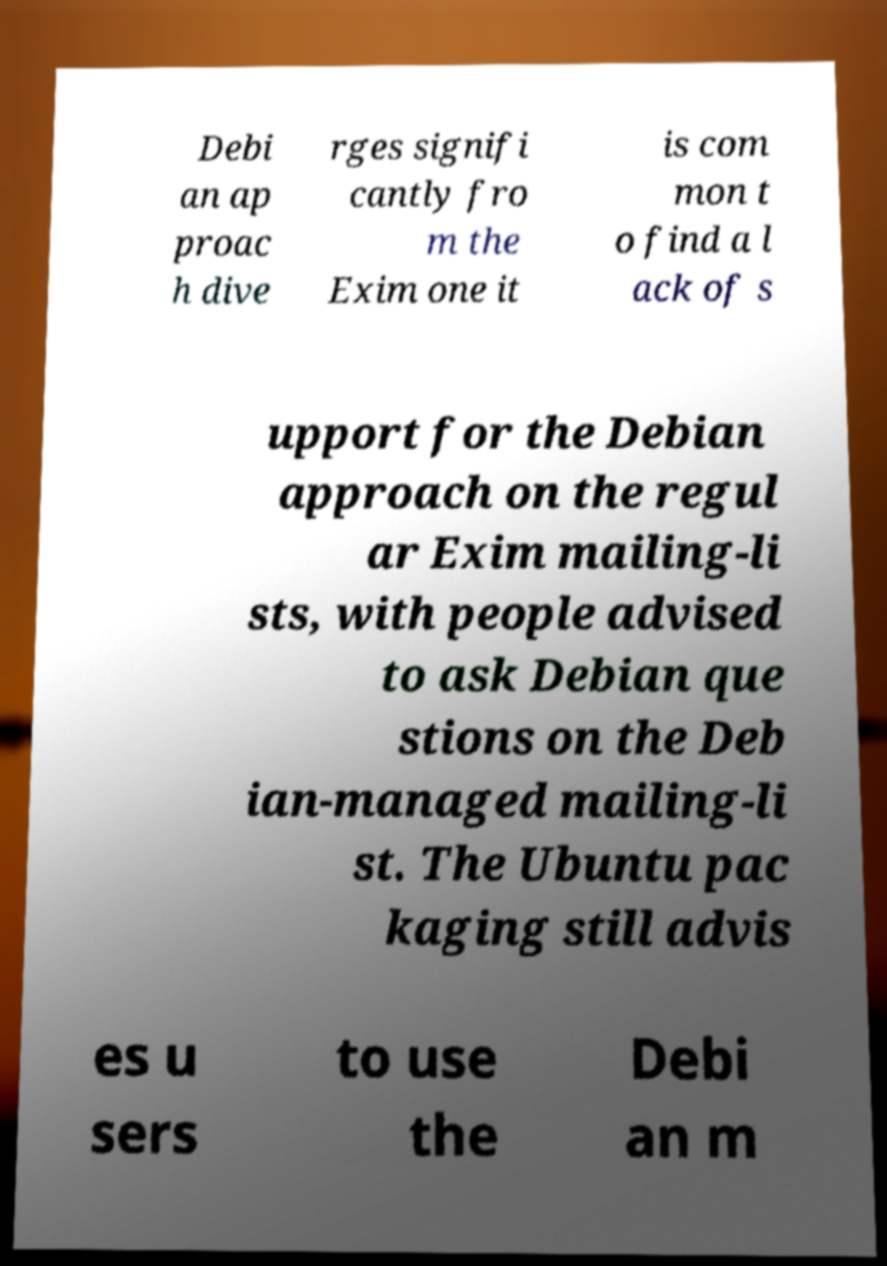Can you accurately transcribe the text from the provided image for me? Debi an ap proac h dive rges signifi cantly fro m the Exim one it is com mon t o find a l ack of s upport for the Debian approach on the regul ar Exim mailing-li sts, with people advised to ask Debian que stions on the Deb ian-managed mailing-li st. The Ubuntu pac kaging still advis es u sers to use the Debi an m 